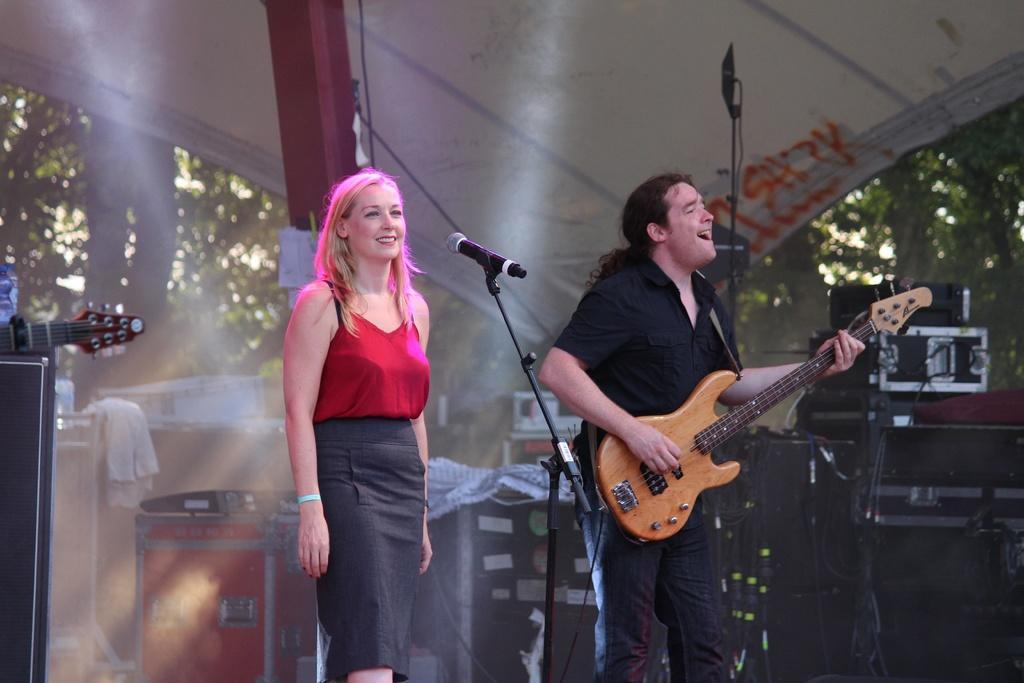Describe this image in one or two sentences. In this picture we can see a man standing in front of a mike playing guitar and singing. We can see a woman standing in front of a mike and smiling. 